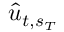<formula> <loc_0><loc_0><loc_500><loc_500>\hat { u } _ { t , s _ { T } }</formula> 